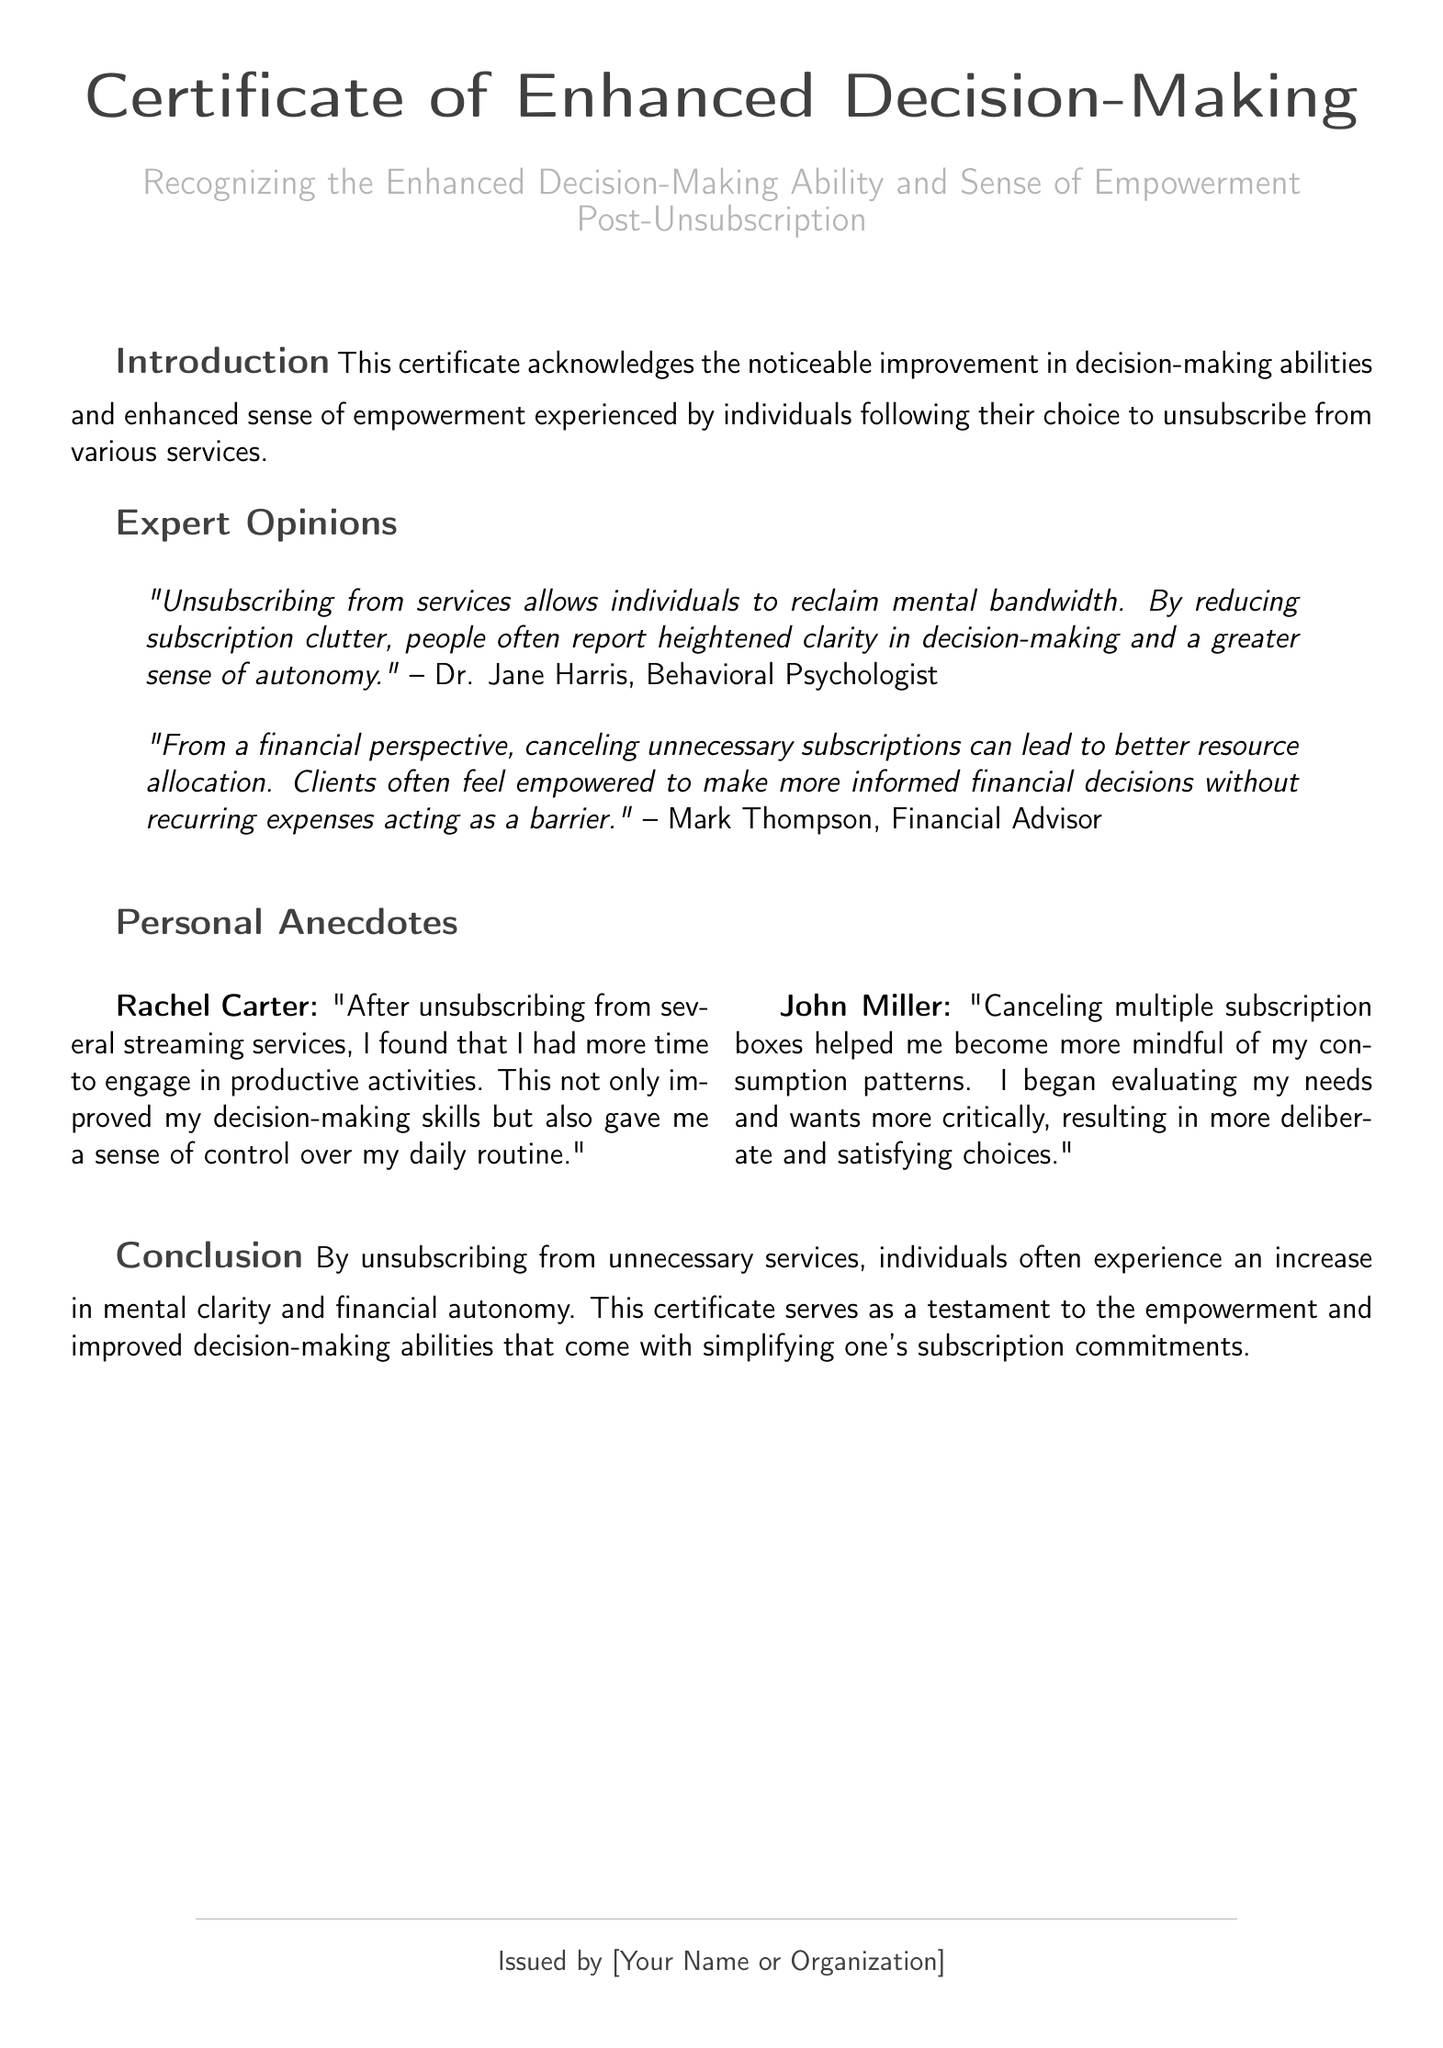What is the title of the certificate? The title of the certificate is the heading presented at the top of the document.
Answer: Certificate of Enhanced Decision-Making Who issued the certificate? The issuing authority or individual is mentioned at the bottom of the document.
Answer: [Your Name or Organization] What is the main theme of the document? The main theme is stated in the introductory section of the certificate.
Answer: Enhanced decision-making ability Who is quoted as a Behavioral Psychologist? The document contains an expert opinion with a specific attribution.
Answer: Dr. Jane Harris What personal experience did Rachel Carter share? Rachel Carter's experience is presented in the personal anecdotes section of the document.
Answer: More time to engage in productive activities What financial benefit is mentioned regarding unsubscription? The document mentions aspects of financial benefits within the expert opinions.
Answer: Better resource allocation How does John Miller describe his changes after unsubscribing? John Miller shares a personal change in perspective following unsubscription.
Answer: More mindful of consumption patterns What color is used for the main text? The document specifies colors used for different elements, including the main text.
Answer: RGB(64,64,64) What does the conclusion state about unsubscribing? The conclusion summarizes the overall findings detailed in the certificate.
Answer: Increase in mental clarity and financial autonomy 